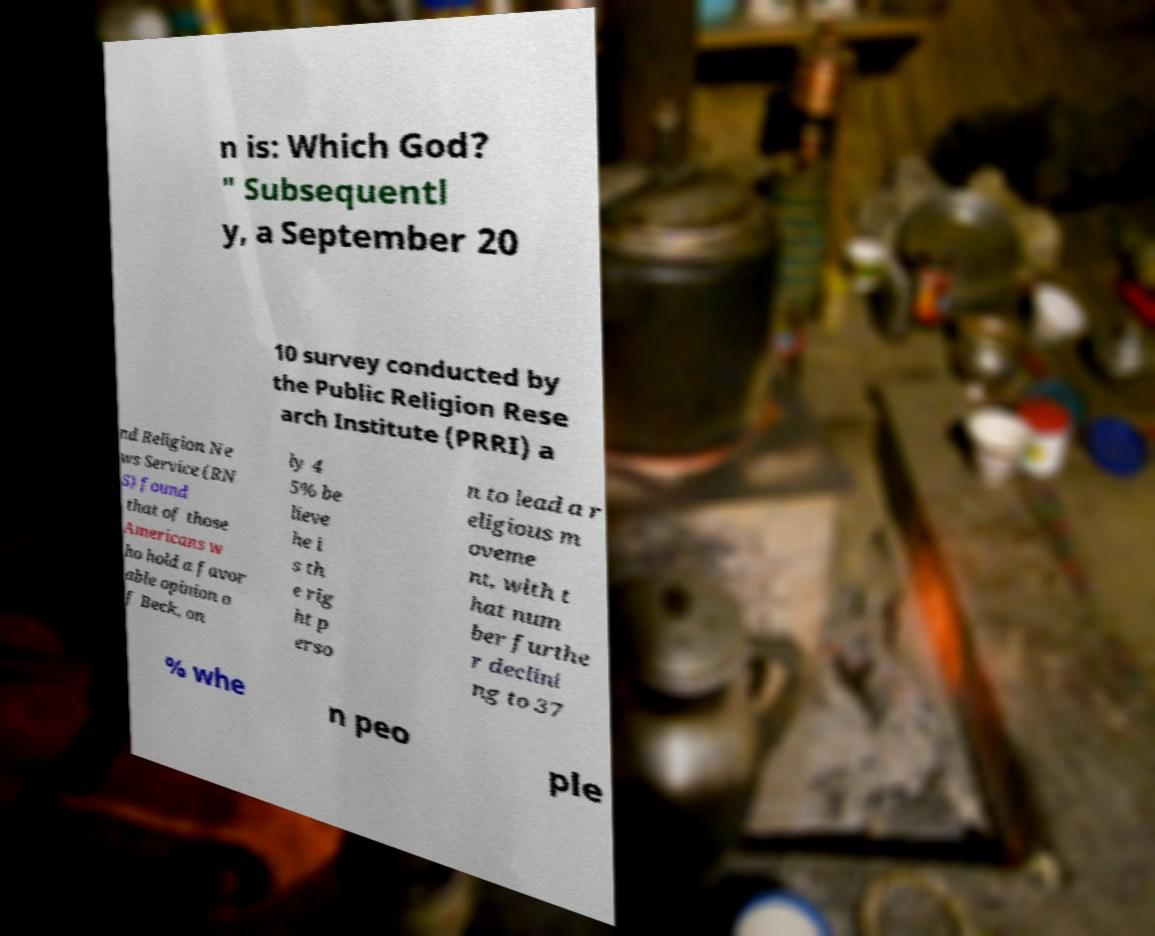There's text embedded in this image that I need extracted. Can you transcribe it verbatim? n is: Which God? " Subsequentl y, a September 20 10 survey conducted by the Public Religion Rese arch Institute (PRRI) a nd Religion Ne ws Service (RN S) found that of those Americans w ho hold a favor able opinion o f Beck, on ly 4 5% be lieve he i s th e rig ht p erso n to lead a r eligious m oveme nt, with t hat num ber furthe r declini ng to 37 % whe n peo ple 